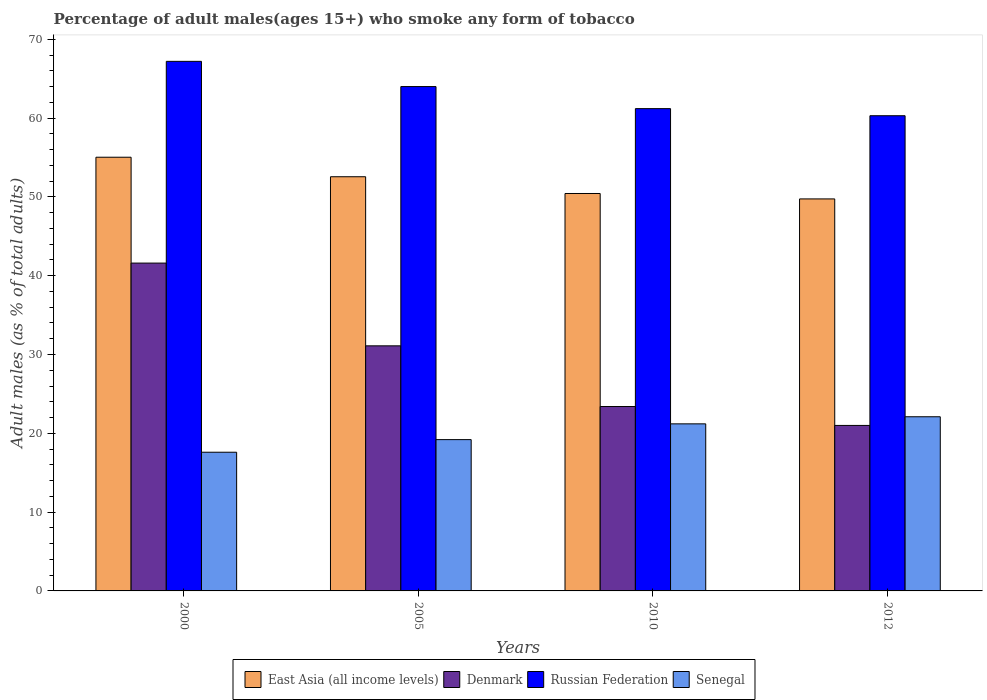How many different coloured bars are there?
Offer a terse response. 4. How many groups of bars are there?
Provide a succinct answer. 4. Are the number of bars on each tick of the X-axis equal?
Your response must be concise. Yes. How many bars are there on the 4th tick from the right?
Offer a very short reply. 4. What is the percentage of adult males who smoke in Senegal in 2012?
Your response must be concise. 22.1. Across all years, what is the maximum percentage of adult males who smoke in Senegal?
Provide a short and direct response. 22.1. Across all years, what is the minimum percentage of adult males who smoke in Russian Federation?
Your response must be concise. 60.3. In which year was the percentage of adult males who smoke in Denmark maximum?
Your answer should be very brief. 2000. What is the total percentage of adult males who smoke in Denmark in the graph?
Provide a short and direct response. 117.1. What is the difference between the percentage of adult males who smoke in Denmark in 2000 and that in 2012?
Provide a short and direct response. 20.6. What is the difference between the percentage of adult males who smoke in Denmark in 2005 and the percentage of adult males who smoke in Senegal in 2012?
Your response must be concise. 9. What is the average percentage of adult males who smoke in Denmark per year?
Provide a short and direct response. 29.27. In the year 2012, what is the difference between the percentage of adult males who smoke in East Asia (all income levels) and percentage of adult males who smoke in Denmark?
Make the answer very short. 28.74. What is the ratio of the percentage of adult males who smoke in Russian Federation in 2000 to that in 2005?
Your response must be concise. 1.05. What is the difference between the highest and the second highest percentage of adult males who smoke in East Asia (all income levels)?
Your answer should be very brief. 2.48. What is the difference between the highest and the lowest percentage of adult males who smoke in Russian Federation?
Offer a terse response. 6.9. In how many years, is the percentage of adult males who smoke in Russian Federation greater than the average percentage of adult males who smoke in Russian Federation taken over all years?
Ensure brevity in your answer.  2. Is the sum of the percentage of adult males who smoke in East Asia (all income levels) in 2010 and 2012 greater than the maximum percentage of adult males who smoke in Russian Federation across all years?
Keep it short and to the point. Yes. Is it the case that in every year, the sum of the percentage of adult males who smoke in Russian Federation and percentage of adult males who smoke in Senegal is greater than the sum of percentage of adult males who smoke in Denmark and percentage of adult males who smoke in East Asia (all income levels)?
Your response must be concise. Yes. What does the 2nd bar from the left in 2010 represents?
Your answer should be very brief. Denmark. What does the 4th bar from the right in 2012 represents?
Make the answer very short. East Asia (all income levels). Is it the case that in every year, the sum of the percentage of adult males who smoke in Russian Federation and percentage of adult males who smoke in Denmark is greater than the percentage of adult males who smoke in East Asia (all income levels)?
Give a very brief answer. Yes. How many bars are there?
Your answer should be compact. 16. Are all the bars in the graph horizontal?
Offer a terse response. No. Does the graph contain any zero values?
Keep it short and to the point. No. Does the graph contain grids?
Keep it short and to the point. No. What is the title of the graph?
Ensure brevity in your answer.  Percentage of adult males(ages 15+) who smoke any form of tobacco. Does "Australia" appear as one of the legend labels in the graph?
Offer a very short reply. No. What is the label or title of the X-axis?
Provide a succinct answer. Years. What is the label or title of the Y-axis?
Give a very brief answer. Adult males (as % of total adults). What is the Adult males (as % of total adults) of East Asia (all income levels) in 2000?
Your response must be concise. 55.03. What is the Adult males (as % of total adults) in Denmark in 2000?
Ensure brevity in your answer.  41.6. What is the Adult males (as % of total adults) in Russian Federation in 2000?
Your answer should be compact. 67.2. What is the Adult males (as % of total adults) in Senegal in 2000?
Your answer should be very brief. 17.6. What is the Adult males (as % of total adults) in East Asia (all income levels) in 2005?
Provide a short and direct response. 52.56. What is the Adult males (as % of total adults) of Denmark in 2005?
Give a very brief answer. 31.1. What is the Adult males (as % of total adults) in Russian Federation in 2005?
Make the answer very short. 64. What is the Adult males (as % of total adults) in Senegal in 2005?
Keep it short and to the point. 19.2. What is the Adult males (as % of total adults) of East Asia (all income levels) in 2010?
Provide a succinct answer. 50.43. What is the Adult males (as % of total adults) of Denmark in 2010?
Provide a succinct answer. 23.4. What is the Adult males (as % of total adults) in Russian Federation in 2010?
Offer a very short reply. 61.2. What is the Adult males (as % of total adults) in Senegal in 2010?
Provide a succinct answer. 21.2. What is the Adult males (as % of total adults) of East Asia (all income levels) in 2012?
Provide a succinct answer. 49.74. What is the Adult males (as % of total adults) of Russian Federation in 2012?
Your answer should be compact. 60.3. What is the Adult males (as % of total adults) in Senegal in 2012?
Give a very brief answer. 22.1. Across all years, what is the maximum Adult males (as % of total adults) in East Asia (all income levels)?
Make the answer very short. 55.03. Across all years, what is the maximum Adult males (as % of total adults) of Denmark?
Offer a terse response. 41.6. Across all years, what is the maximum Adult males (as % of total adults) in Russian Federation?
Your answer should be compact. 67.2. Across all years, what is the maximum Adult males (as % of total adults) in Senegal?
Give a very brief answer. 22.1. Across all years, what is the minimum Adult males (as % of total adults) in East Asia (all income levels)?
Give a very brief answer. 49.74. Across all years, what is the minimum Adult males (as % of total adults) in Russian Federation?
Your answer should be very brief. 60.3. What is the total Adult males (as % of total adults) in East Asia (all income levels) in the graph?
Offer a terse response. 207.77. What is the total Adult males (as % of total adults) in Denmark in the graph?
Your response must be concise. 117.1. What is the total Adult males (as % of total adults) of Russian Federation in the graph?
Keep it short and to the point. 252.7. What is the total Adult males (as % of total adults) of Senegal in the graph?
Your answer should be very brief. 80.1. What is the difference between the Adult males (as % of total adults) of East Asia (all income levels) in 2000 and that in 2005?
Ensure brevity in your answer.  2.48. What is the difference between the Adult males (as % of total adults) in Senegal in 2000 and that in 2005?
Offer a terse response. -1.6. What is the difference between the Adult males (as % of total adults) in East Asia (all income levels) in 2000 and that in 2010?
Give a very brief answer. 4.6. What is the difference between the Adult males (as % of total adults) of East Asia (all income levels) in 2000 and that in 2012?
Provide a succinct answer. 5.29. What is the difference between the Adult males (as % of total adults) in Denmark in 2000 and that in 2012?
Give a very brief answer. 20.6. What is the difference between the Adult males (as % of total adults) of Russian Federation in 2000 and that in 2012?
Your response must be concise. 6.9. What is the difference between the Adult males (as % of total adults) in East Asia (all income levels) in 2005 and that in 2010?
Ensure brevity in your answer.  2.13. What is the difference between the Adult males (as % of total adults) of Denmark in 2005 and that in 2010?
Your answer should be compact. 7.7. What is the difference between the Adult males (as % of total adults) of Senegal in 2005 and that in 2010?
Keep it short and to the point. -2. What is the difference between the Adult males (as % of total adults) in East Asia (all income levels) in 2005 and that in 2012?
Your answer should be very brief. 2.81. What is the difference between the Adult males (as % of total adults) in Denmark in 2005 and that in 2012?
Provide a succinct answer. 10.1. What is the difference between the Adult males (as % of total adults) in Russian Federation in 2005 and that in 2012?
Your answer should be compact. 3.7. What is the difference between the Adult males (as % of total adults) of East Asia (all income levels) in 2010 and that in 2012?
Your answer should be compact. 0.69. What is the difference between the Adult males (as % of total adults) of Denmark in 2010 and that in 2012?
Ensure brevity in your answer.  2.4. What is the difference between the Adult males (as % of total adults) in East Asia (all income levels) in 2000 and the Adult males (as % of total adults) in Denmark in 2005?
Keep it short and to the point. 23.93. What is the difference between the Adult males (as % of total adults) in East Asia (all income levels) in 2000 and the Adult males (as % of total adults) in Russian Federation in 2005?
Make the answer very short. -8.97. What is the difference between the Adult males (as % of total adults) of East Asia (all income levels) in 2000 and the Adult males (as % of total adults) of Senegal in 2005?
Your answer should be very brief. 35.83. What is the difference between the Adult males (as % of total adults) in Denmark in 2000 and the Adult males (as % of total adults) in Russian Federation in 2005?
Keep it short and to the point. -22.4. What is the difference between the Adult males (as % of total adults) of Denmark in 2000 and the Adult males (as % of total adults) of Senegal in 2005?
Offer a terse response. 22.4. What is the difference between the Adult males (as % of total adults) in Russian Federation in 2000 and the Adult males (as % of total adults) in Senegal in 2005?
Keep it short and to the point. 48. What is the difference between the Adult males (as % of total adults) in East Asia (all income levels) in 2000 and the Adult males (as % of total adults) in Denmark in 2010?
Make the answer very short. 31.63. What is the difference between the Adult males (as % of total adults) in East Asia (all income levels) in 2000 and the Adult males (as % of total adults) in Russian Federation in 2010?
Provide a short and direct response. -6.17. What is the difference between the Adult males (as % of total adults) of East Asia (all income levels) in 2000 and the Adult males (as % of total adults) of Senegal in 2010?
Provide a short and direct response. 33.83. What is the difference between the Adult males (as % of total adults) in Denmark in 2000 and the Adult males (as % of total adults) in Russian Federation in 2010?
Your answer should be very brief. -19.6. What is the difference between the Adult males (as % of total adults) in Denmark in 2000 and the Adult males (as % of total adults) in Senegal in 2010?
Offer a very short reply. 20.4. What is the difference between the Adult males (as % of total adults) in Russian Federation in 2000 and the Adult males (as % of total adults) in Senegal in 2010?
Your response must be concise. 46. What is the difference between the Adult males (as % of total adults) in East Asia (all income levels) in 2000 and the Adult males (as % of total adults) in Denmark in 2012?
Offer a very short reply. 34.03. What is the difference between the Adult males (as % of total adults) of East Asia (all income levels) in 2000 and the Adult males (as % of total adults) of Russian Federation in 2012?
Make the answer very short. -5.27. What is the difference between the Adult males (as % of total adults) in East Asia (all income levels) in 2000 and the Adult males (as % of total adults) in Senegal in 2012?
Ensure brevity in your answer.  32.93. What is the difference between the Adult males (as % of total adults) in Denmark in 2000 and the Adult males (as % of total adults) in Russian Federation in 2012?
Keep it short and to the point. -18.7. What is the difference between the Adult males (as % of total adults) in Russian Federation in 2000 and the Adult males (as % of total adults) in Senegal in 2012?
Offer a terse response. 45.1. What is the difference between the Adult males (as % of total adults) of East Asia (all income levels) in 2005 and the Adult males (as % of total adults) of Denmark in 2010?
Offer a very short reply. 29.16. What is the difference between the Adult males (as % of total adults) in East Asia (all income levels) in 2005 and the Adult males (as % of total adults) in Russian Federation in 2010?
Make the answer very short. -8.64. What is the difference between the Adult males (as % of total adults) in East Asia (all income levels) in 2005 and the Adult males (as % of total adults) in Senegal in 2010?
Offer a terse response. 31.36. What is the difference between the Adult males (as % of total adults) in Denmark in 2005 and the Adult males (as % of total adults) in Russian Federation in 2010?
Keep it short and to the point. -30.1. What is the difference between the Adult males (as % of total adults) in Denmark in 2005 and the Adult males (as % of total adults) in Senegal in 2010?
Your answer should be very brief. 9.9. What is the difference between the Adult males (as % of total adults) in Russian Federation in 2005 and the Adult males (as % of total adults) in Senegal in 2010?
Offer a very short reply. 42.8. What is the difference between the Adult males (as % of total adults) in East Asia (all income levels) in 2005 and the Adult males (as % of total adults) in Denmark in 2012?
Provide a succinct answer. 31.56. What is the difference between the Adult males (as % of total adults) of East Asia (all income levels) in 2005 and the Adult males (as % of total adults) of Russian Federation in 2012?
Provide a succinct answer. -7.74. What is the difference between the Adult males (as % of total adults) of East Asia (all income levels) in 2005 and the Adult males (as % of total adults) of Senegal in 2012?
Your answer should be compact. 30.46. What is the difference between the Adult males (as % of total adults) in Denmark in 2005 and the Adult males (as % of total adults) in Russian Federation in 2012?
Offer a terse response. -29.2. What is the difference between the Adult males (as % of total adults) of Denmark in 2005 and the Adult males (as % of total adults) of Senegal in 2012?
Your answer should be compact. 9. What is the difference between the Adult males (as % of total adults) of Russian Federation in 2005 and the Adult males (as % of total adults) of Senegal in 2012?
Your answer should be very brief. 41.9. What is the difference between the Adult males (as % of total adults) in East Asia (all income levels) in 2010 and the Adult males (as % of total adults) in Denmark in 2012?
Keep it short and to the point. 29.43. What is the difference between the Adult males (as % of total adults) of East Asia (all income levels) in 2010 and the Adult males (as % of total adults) of Russian Federation in 2012?
Provide a succinct answer. -9.87. What is the difference between the Adult males (as % of total adults) of East Asia (all income levels) in 2010 and the Adult males (as % of total adults) of Senegal in 2012?
Give a very brief answer. 28.33. What is the difference between the Adult males (as % of total adults) of Denmark in 2010 and the Adult males (as % of total adults) of Russian Federation in 2012?
Provide a short and direct response. -36.9. What is the difference between the Adult males (as % of total adults) in Denmark in 2010 and the Adult males (as % of total adults) in Senegal in 2012?
Keep it short and to the point. 1.3. What is the difference between the Adult males (as % of total adults) in Russian Federation in 2010 and the Adult males (as % of total adults) in Senegal in 2012?
Offer a terse response. 39.1. What is the average Adult males (as % of total adults) of East Asia (all income levels) per year?
Your response must be concise. 51.94. What is the average Adult males (as % of total adults) in Denmark per year?
Make the answer very short. 29.27. What is the average Adult males (as % of total adults) in Russian Federation per year?
Provide a short and direct response. 63.17. What is the average Adult males (as % of total adults) of Senegal per year?
Ensure brevity in your answer.  20.02. In the year 2000, what is the difference between the Adult males (as % of total adults) in East Asia (all income levels) and Adult males (as % of total adults) in Denmark?
Keep it short and to the point. 13.43. In the year 2000, what is the difference between the Adult males (as % of total adults) in East Asia (all income levels) and Adult males (as % of total adults) in Russian Federation?
Provide a short and direct response. -12.17. In the year 2000, what is the difference between the Adult males (as % of total adults) of East Asia (all income levels) and Adult males (as % of total adults) of Senegal?
Provide a succinct answer. 37.43. In the year 2000, what is the difference between the Adult males (as % of total adults) in Denmark and Adult males (as % of total adults) in Russian Federation?
Your answer should be very brief. -25.6. In the year 2000, what is the difference between the Adult males (as % of total adults) in Russian Federation and Adult males (as % of total adults) in Senegal?
Your response must be concise. 49.6. In the year 2005, what is the difference between the Adult males (as % of total adults) of East Asia (all income levels) and Adult males (as % of total adults) of Denmark?
Offer a terse response. 21.46. In the year 2005, what is the difference between the Adult males (as % of total adults) of East Asia (all income levels) and Adult males (as % of total adults) of Russian Federation?
Your answer should be very brief. -11.44. In the year 2005, what is the difference between the Adult males (as % of total adults) in East Asia (all income levels) and Adult males (as % of total adults) in Senegal?
Offer a very short reply. 33.36. In the year 2005, what is the difference between the Adult males (as % of total adults) of Denmark and Adult males (as % of total adults) of Russian Federation?
Your response must be concise. -32.9. In the year 2005, what is the difference between the Adult males (as % of total adults) in Denmark and Adult males (as % of total adults) in Senegal?
Your response must be concise. 11.9. In the year 2005, what is the difference between the Adult males (as % of total adults) of Russian Federation and Adult males (as % of total adults) of Senegal?
Offer a terse response. 44.8. In the year 2010, what is the difference between the Adult males (as % of total adults) of East Asia (all income levels) and Adult males (as % of total adults) of Denmark?
Give a very brief answer. 27.03. In the year 2010, what is the difference between the Adult males (as % of total adults) in East Asia (all income levels) and Adult males (as % of total adults) in Russian Federation?
Your answer should be very brief. -10.77. In the year 2010, what is the difference between the Adult males (as % of total adults) in East Asia (all income levels) and Adult males (as % of total adults) in Senegal?
Provide a short and direct response. 29.23. In the year 2010, what is the difference between the Adult males (as % of total adults) in Denmark and Adult males (as % of total adults) in Russian Federation?
Offer a terse response. -37.8. In the year 2010, what is the difference between the Adult males (as % of total adults) of Denmark and Adult males (as % of total adults) of Senegal?
Ensure brevity in your answer.  2.2. In the year 2012, what is the difference between the Adult males (as % of total adults) of East Asia (all income levels) and Adult males (as % of total adults) of Denmark?
Give a very brief answer. 28.74. In the year 2012, what is the difference between the Adult males (as % of total adults) in East Asia (all income levels) and Adult males (as % of total adults) in Russian Federation?
Offer a very short reply. -10.56. In the year 2012, what is the difference between the Adult males (as % of total adults) of East Asia (all income levels) and Adult males (as % of total adults) of Senegal?
Your response must be concise. 27.64. In the year 2012, what is the difference between the Adult males (as % of total adults) in Denmark and Adult males (as % of total adults) in Russian Federation?
Keep it short and to the point. -39.3. In the year 2012, what is the difference between the Adult males (as % of total adults) of Russian Federation and Adult males (as % of total adults) of Senegal?
Give a very brief answer. 38.2. What is the ratio of the Adult males (as % of total adults) in East Asia (all income levels) in 2000 to that in 2005?
Your response must be concise. 1.05. What is the ratio of the Adult males (as % of total adults) in Denmark in 2000 to that in 2005?
Your answer should be compact. 1.34. What is the ratio of the Adult males (as % of total adults) of Senegal in 2000 to that in 2005?
Your response must be concise. 0.92. What is the ratio of the Adult males (as % of total adults) of East Asia (all income levels) in 2000 to that in 2010?
Your answer should be very brief. 1.09. What is the ratio of the Adult males (as % of total adults) of Denmark in 2000 to that in 2010?
Provide a succinct answer. 1.78. What is the ratio of the Adult males (as % of total adults) in Russian Federation in 2000 to that in 2010?
Offer a terse response. 1.1. What is the ratio of the Adult males (as % of total adults) in Senegal in 2000 to that in 2010?
Offer a terse response. 0.83. What is the ratio of the Adult males (as % of total adults) of East Asia (all income levels) in 2000 to that in 2012?
Give a very brief answer. 1.11. What is the ratio of the Adult males (as % of total adults) of Denmark in 2000 to that in 2012?
Your response must be concise. 1.98. What is the ratio of the Adult males (as % of total adults) in Russian Federation in 2000 to that in 2012?
Keep it short and to the point. 1.11. What is the ratio of the Adult males (as % of total adults) in Senegal in 2000 to that in 2012?
Offer a terse response. 0.8. What is the ratio of the Adult males (as % of total adults) in East Asia (all income levels) in 2005 to that in 2010?
Provide a short and direct response. 1.04. What is the ratio of the Adult males (as % of total adults) of Denmark in 2005 to that in 2010?
Give a very brief answer. 1.33. What is the ratio of the Adult males (as % of total adults) in Russian Federation in 2005 to that in 2010?
Keep it short and to the point. 1.05. What is the ratio of the Adult males (as % of total adults) in Senegal in 2005 to that in 2010?
Offer a very short reply. 0.91. What is the ratio of the Adult males (as % of total adults) of East Asia (all income levels) in 2005 to that in 2012?
Make the answer very short. 1.06. What is the ratio of the Adult males (as % of total adults) in Denmark in 2005 to that in 2012?
Provide a short and direct response. 1.48. What is the ratio of the Adult males (as % of total adults) of Russian Federation in 2005 to that in 2012?
Give a very brief answer. 1.06. What is the ratio of the Adult males (as % of total adults) of Senegal in 2005 to that in 2012?
Ensure brevity in your answer.  0.87. What is the ratio of the Adult males (as % of total adults) of East Asia (all income levels) in 2010 to that in 2012?
Offer a terse response. 1.01. What is the ratio of the Adult males (as % of total adults) of Denmark in 2010 to that in 2012?
Your answer should be very brief. 1.11. What is the ratio of the Adult males (as % of total adults) of Russian Federation in 2010 to that in 2012?
Provide a succinct answer. 1.01. What is the ratio of the Adult males (as % of total adults) in Senegal in 2010 to that in 2012?
Make the answer very short. 0.96. What is the difference between the highest and the second highest Adult males (as % of total adults) of East Asia (all income levels)?
Keep it short and to the point. 2.48. What is the difference between the highest and the second highest Adult males (as % of total adults) of Russian Federation?
Your answer should be very brief. 3.2. What is the difference between the highest and the second highest Adult males (as % of total adults) in Senegal?
Your answer should be very brief. 0.9. What is the difference between the highest and the lowest Adult males (as % of total adults) of East Asia (all income levels)?
Your answer should be compact. 5.29. What is the difference between the highest and the lowest Adult males (as % of total adults) of Denmark?
Give a very brief answer. 20.6. 